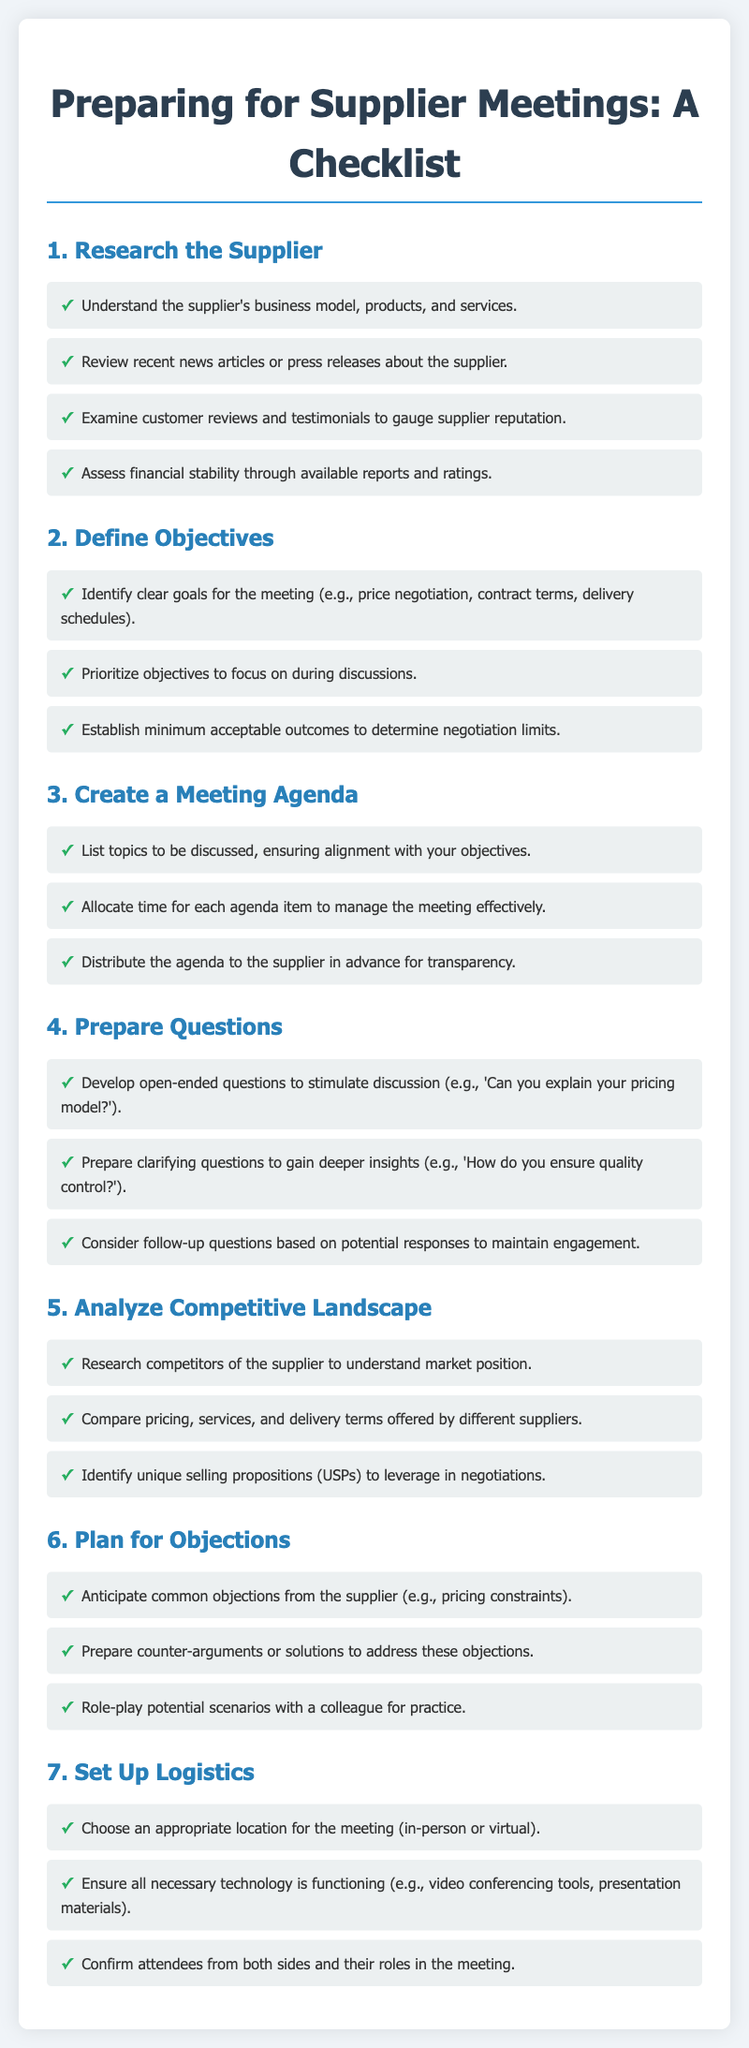what is the title of the document? The title of the document is specified in the title tag within the HTML code, which describes its content.
Answer: Preparing for Supplier Meetings: A Checklist how many main sections are in the document? The document contains specific headings that represent main sections, which can be counted for identification.
Answer: seven what is one objective to define before the meeting? The document lists objectives in a section that includes clear goals for the meeting, implying tasks to be defined.
Answer: price negotiation what should be prepared to stimulate discussion? The document mentions developing specific types of questions to encourage conversation in meetings, indicating key preparation.
Answer: open-ended questions what type of questions should be prepared for deeper insights? The document specifies the category of questions that are aimed at gaining a better understanding of the supplier's offerings and practices.
Answer: clarifying questions who should confirm their roles in the meeting? The document discusses logistics and mentions attendees who need to be arranged and informed before the meeting.
Answer: attendees what is an effective strategy to address potential objections? The document highlights anticipatory measures for challenges that may arise during negotiations, emphasizing the importance of preparedness.
Answer: prepare counter-arguments 